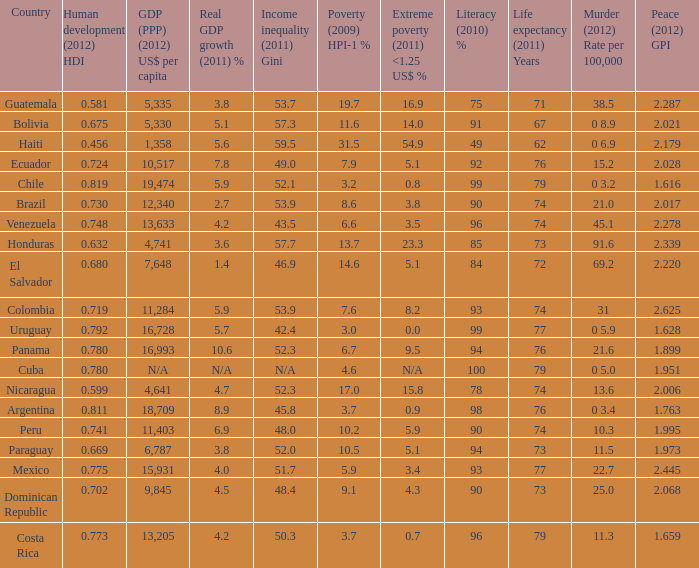What is the total poverty (2009) HPI-1 % when the extreme poverty (2011) <1.25 US$ % of 16.9, and the human development (2012) HDI is less than 0.581? None. 